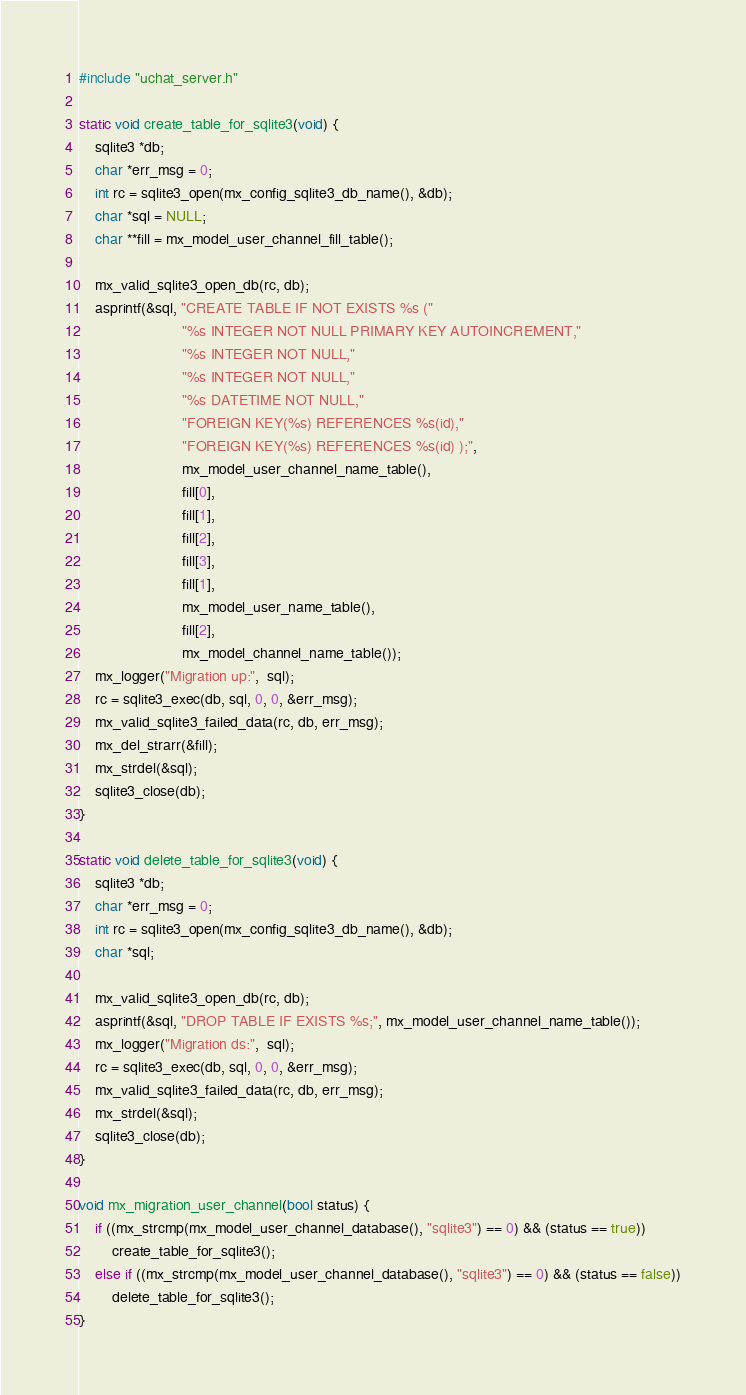Convert code to text. <code><loc_0><loc_0><loc_500><loc_500><_C_>#include "uchat_server.h"

static void create_table_for_sqlite3(void) {
    sqlite3 *db;
    char *err_msg = 0;
    int rc = sqlite3_open(mx_config_sqlite3_db_name(), &db);
    char *sql = NULL;
    char **fill = mx_model_user_channel_fill_table();

    mx_valid_sqlite3_open_db(rc, db);
    asprintf(&sql, "CREATE TABLE IF NOT EXISTS %s ("
                         "%s INTEGER NOT NULL PRIMARY KEY AUTOINCREMENT,"
                         "%s INTEGER NOT NULL,"
                         "%s INTEGER NOT NULL,"
                         "%s DATETIME NOT NULL,"
                         "FOREIGN KEY(%s) REFERENCES %s(id),"
                         "FOREIGN KEY(%s) REFERENCES %s(id) );",
                         mx_model_user_channel_name_table(),
                         fill[0],
                         fill[1],
                         fill[2],
                         fill[3],
                         fill[1],
                         mx_model_user_name_table(),
                         fill[2],
                         mx_model_channel_name_table());
    mx_logger("Migration up:",  sql);
    rc = sqlite3_exec(db, sql, 0, 0, &err_msg);
    mx_valid_sqlite3_failed_data(rc, db, err_msg);
    mx_del_strarr(&fill);
    mx_strdel(&sql);
    sqlite3_close(db);
}

static void delete_table_for_sqlite3(void) {
    sqlite3 *db;
    char *err_msg = 0;
    int rc = sqlite3_open(mx_config_sqlite3_db_name(), &db);
    char *sql;

    mx_valid_sqlite3_open_db(rc, db);
    asprintf(&sql, "DROP TABLE IF EXISTS %s;", mx_model_user_channel_name_table());
    mx_logger("Migration ds:",  sql);
    rc = sqlite3_exec(db, sql, 0, 0, &err_msg);
    mx_valid_sqlite3_failed_data(rc, db, err_msg);
    mx_strdel(&sql);
    sqlite3_close(db);
}

void mx_migration_user_channel(bool status) {
    if ((mx_strcmp(mx_model_user_channel_database(), "sqlite3") == 0) && (status == true))
        create_table_for_sqlite3();
    else if ((mx_strcmp(mx_model_user_channel_database(), "sqlite3") == 0) && (status == false))
        delete_table_for_sqlite3();
}
</code> 